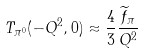Convert formula to latex. <formula><loc_0><loc_0><loc_500><loc_500>T _ { \pi ^ { 0 } } ( - Q ^ { 2 } , 0 ) \approx \frac { 4 } { 3 } \frac { { \widetilde { f } } _ { \pi } } { Q ^ { 2 } }</formula> 